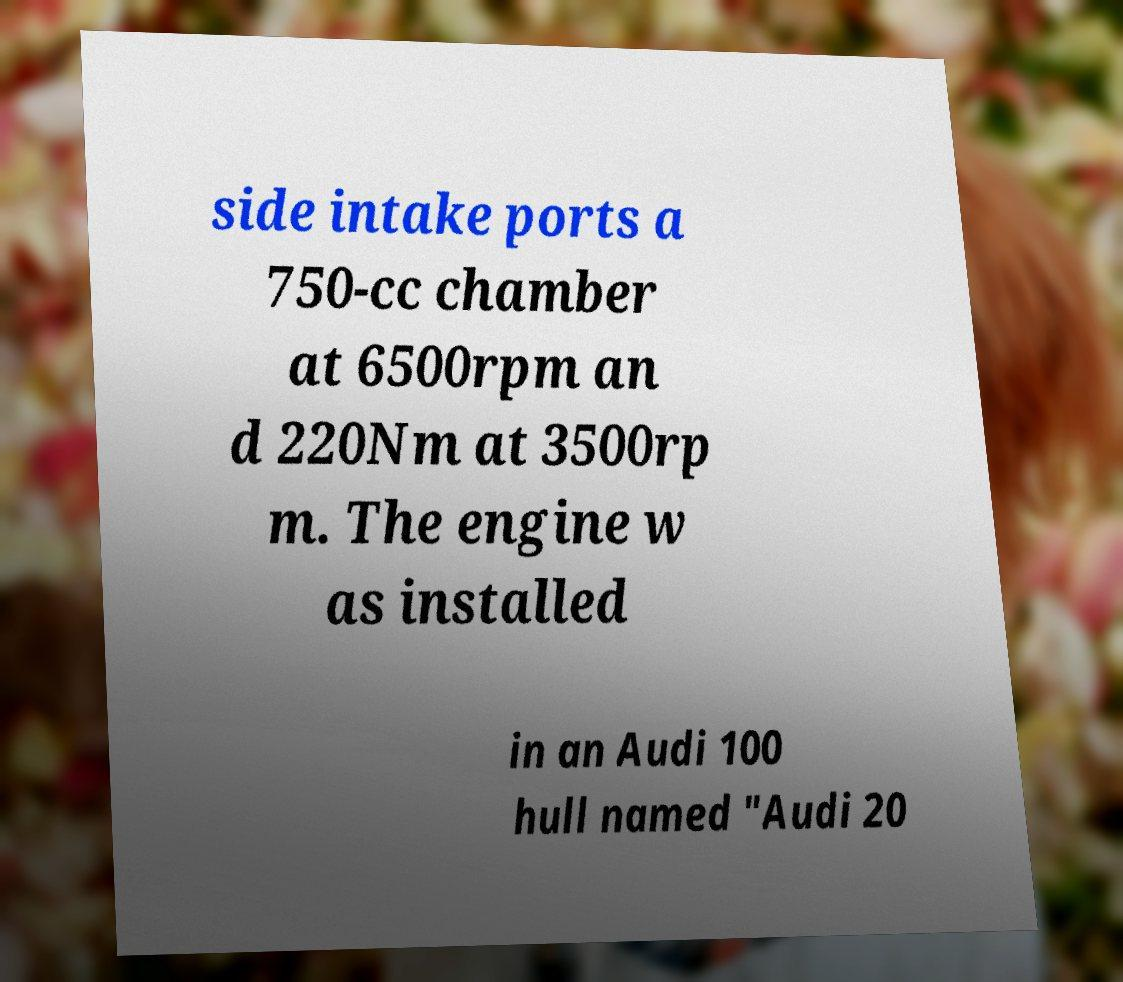For documentation purposes, I need the text within this image transcribed. Could you provide that? side intake ports a 750-cc chamber at 6500rpm an d 220Nm at 3500rp m. The engine w as installed in an Audi 100 hull named "Audi 20 